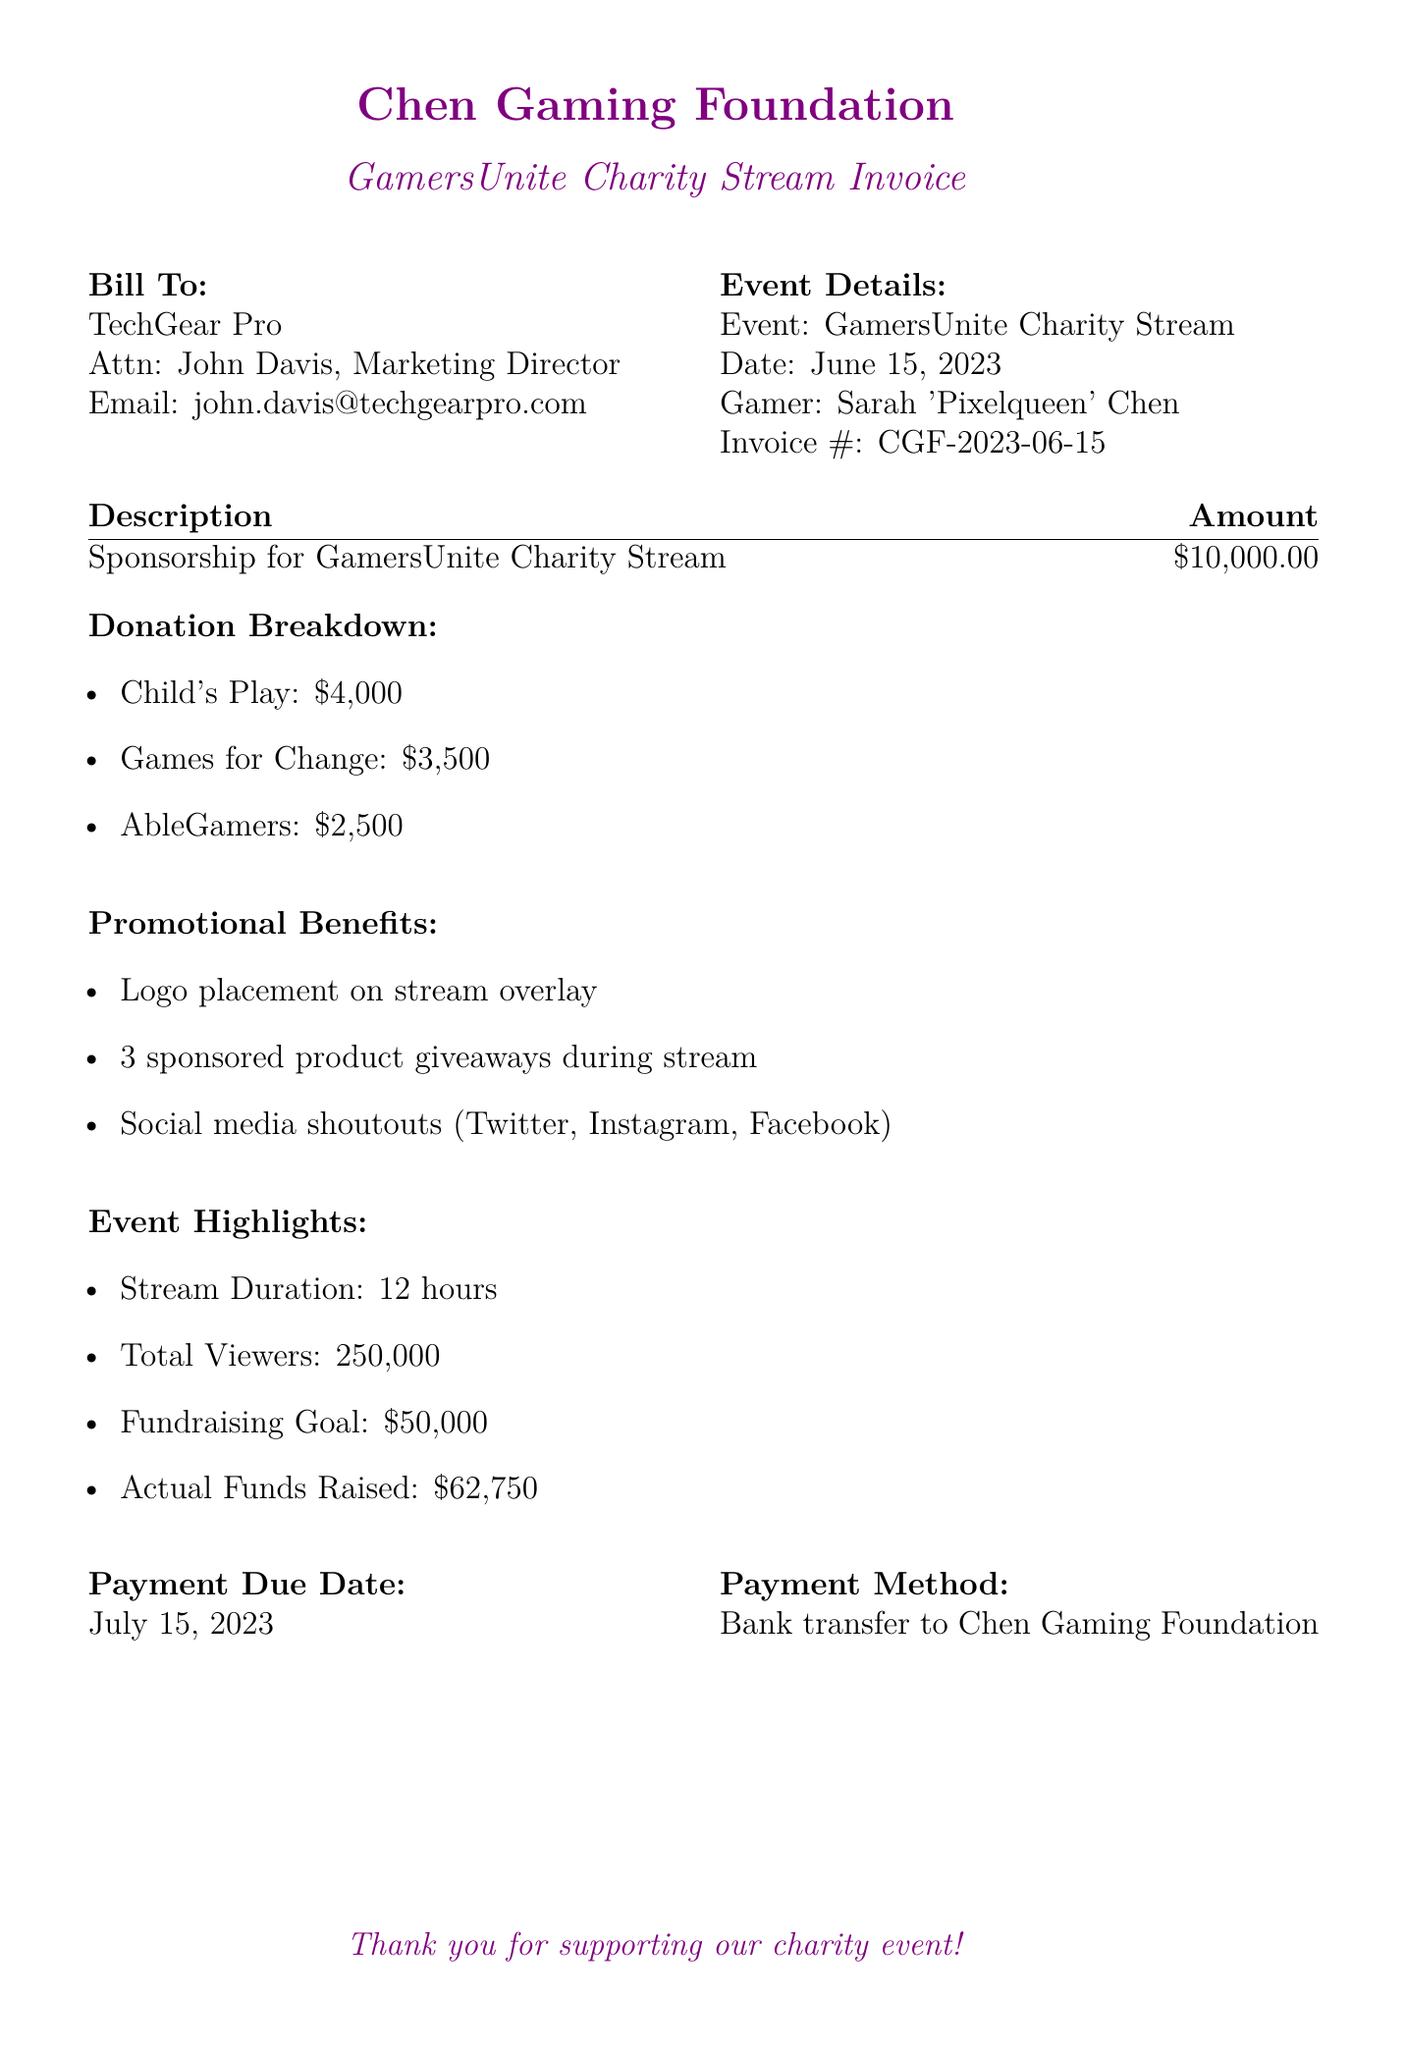What is the event date? The event date is specified in the document under "Event Details."
Answer: June 15, 2023 Who is the marketing director for TechGear Pro? The marketing director's name is listed in the "Bill To" section.
Answer: John Davis What is the total amount of the sponsorship? The sponsorship amount is stated in the "Description" section.
Answer: $10,000.00 How much was donated to Child's Play? The amount donated to Child's Play is included in the "Donation Breakdown."
Answer: $4,000 What was the actual funds raised during the event? The actual funds raised are shown under "Event Highlights."
Answer: $62,750 How many sponsored product giveaways were there? The number of sponsored product giveaways is included under "Promotional Benefits."
Answer: 3 What is the payment due date? The payment due date is noted near the end of the invoice.
Answer: July 15, 2023 What was the fundraising goal for the event? The fundraising goal is specified in the "Event Highlights" section.
Answer: $50,000 What is the email address of the marketing director? The email address is mentioned in the "Bill To" section.
Answer: john.davis@techgearpro.com 